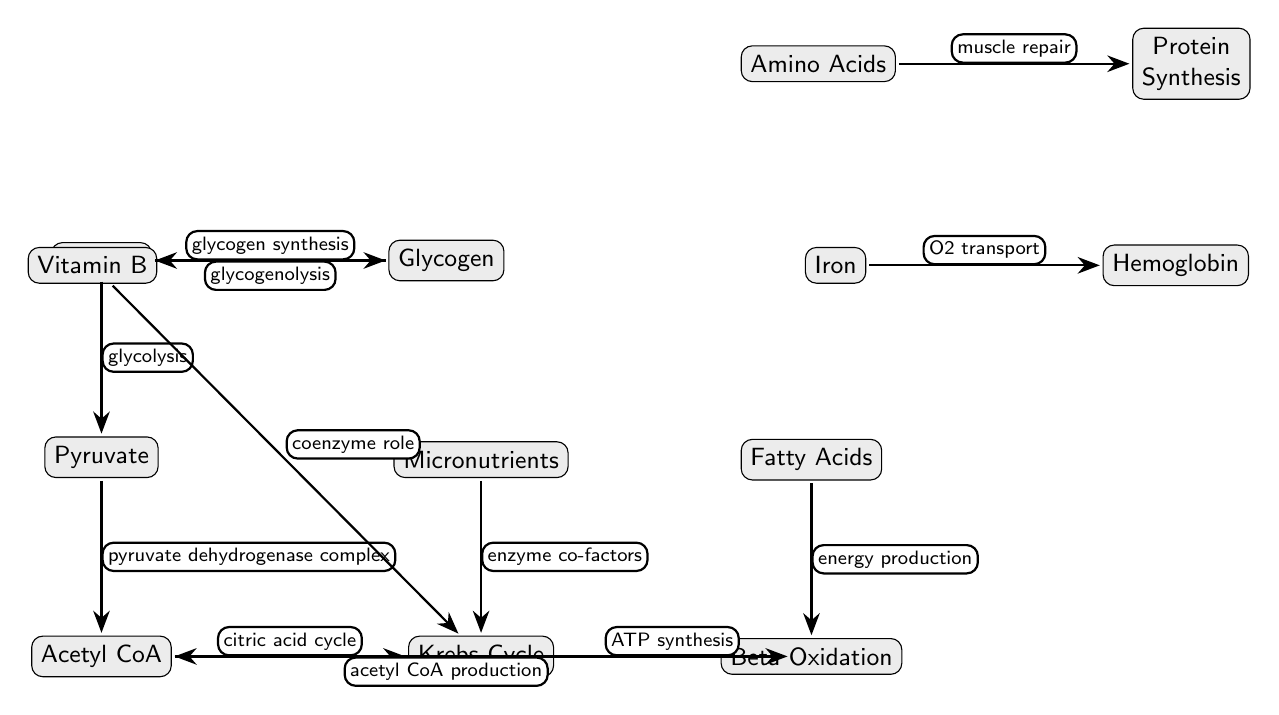What is the first node in the pathway? The diagram begins with the node labeled "Glucose," which is the first step in the metabolic pathway illustrated.
Answer: Glucose How many primary pathways are shown leading from Glucose? There are two arrows originating from "Glucose": one to "Glycogen" (glycogen synthesis) and another to "Pyruvate" (glycolysis), indicating two distinct metabolic pathways.
Answer: 2 What process converts Pyruvate into Acetyl CoA? The process is indicated in the diagram as "pyruvate dehydrogenase complex," which is the enzymatic action that transforms Pyruvate into Acetyl CoA.
Answer: Pyruvate dehydrogenase complex Which macronutrient is involved in energy production through Beta Oxidation? The diagram specifies "Fatty Acids," which are the macronutrients that undergo Beta Oxidation for energy production.
Answer: Fatty Acids What role does Vitamin B play in the Krebs Cycle according to the diagram? The diagram states that Vitamin B has a "coenzyme role" in the Krebs Cycle, indicating its importance in metabolic reactions as a cofactor.
Answer: Coenzyme role Trace the source of ATP production in the diagram. ATP is produced through a series of steps starting from "Acetyl CoA" that enters the "Krebs Cycle," which is followed by an arrow leading to "ATP" under the label "ATP synthesis." Therefore, the source of ATP is Acetyl CoA via the Krebs Cycle.
Answer: Acetyl CoA What type of nutrients do micronutrients provide? The diagram highlights "enzyme co-factors," which are crucial for the functioning of enzymes in various metabolic processes, emphasizing the role of micronutrients in supporting these reactions.
Answer: Enzyme co-factors Which nutrient is specifically shown to support O2 transport? The diagram specifies "Iron," which is linked with the function of Hemoglobin, highlighting its essential role in oxygen transport within the bloodstream.
Answer: Iron What is the output of the Krebs Cycle? The output of the Krebs Cycle is indicated as "ATP," resulting from the various metabolic reactions occurring within the cycle.
Answer: ATP 